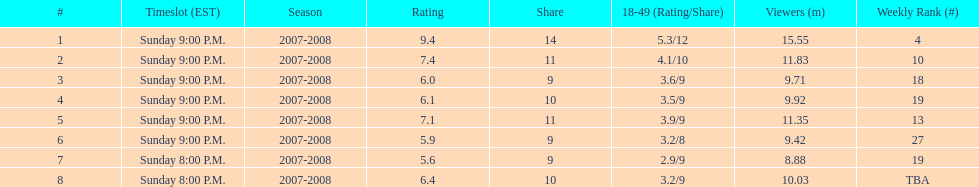Which air date had the least viewers? April 13, 2008. 